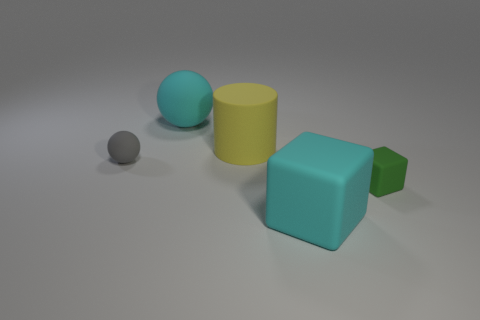Is the number of large things that are behind the green matte cube greater than the number of large yellow shiny balls?
Ensure brevity in your answer.  Yes. What is the size of the cube that is the same material as the small green thing?
Make the answer very short. Large. There is a small green thing; are there any big cyan rubber blocks behind it?
Give a very brief answer. No. Do the green rubber thing and the small gray object have the same shape?
Your answer should be compact. No. There is a rubber sphere behind the sphere in front of the big rubber thing that is to the left of the large yellow object; what is its size?
Ensure brevity in your answer.  Large. What is the material of the cylinder?
Provide a succinct answer. Rubber. Do the gray object and the big cyan matte object that is behind the small gray rubber sphere have the same shape?
Keep it short and to the point. Yes. The sphere in front of the big cyan rubber object that is behind the matte block that is in front of the tiny green rubber block is made of what material?
Offer a terse response. Rubber. What number of red matte spheres are there?
Give a very brief answer. 0. What number of gray things are either big matte cylinders or rubber balls?
Your response must be concise. 1. 